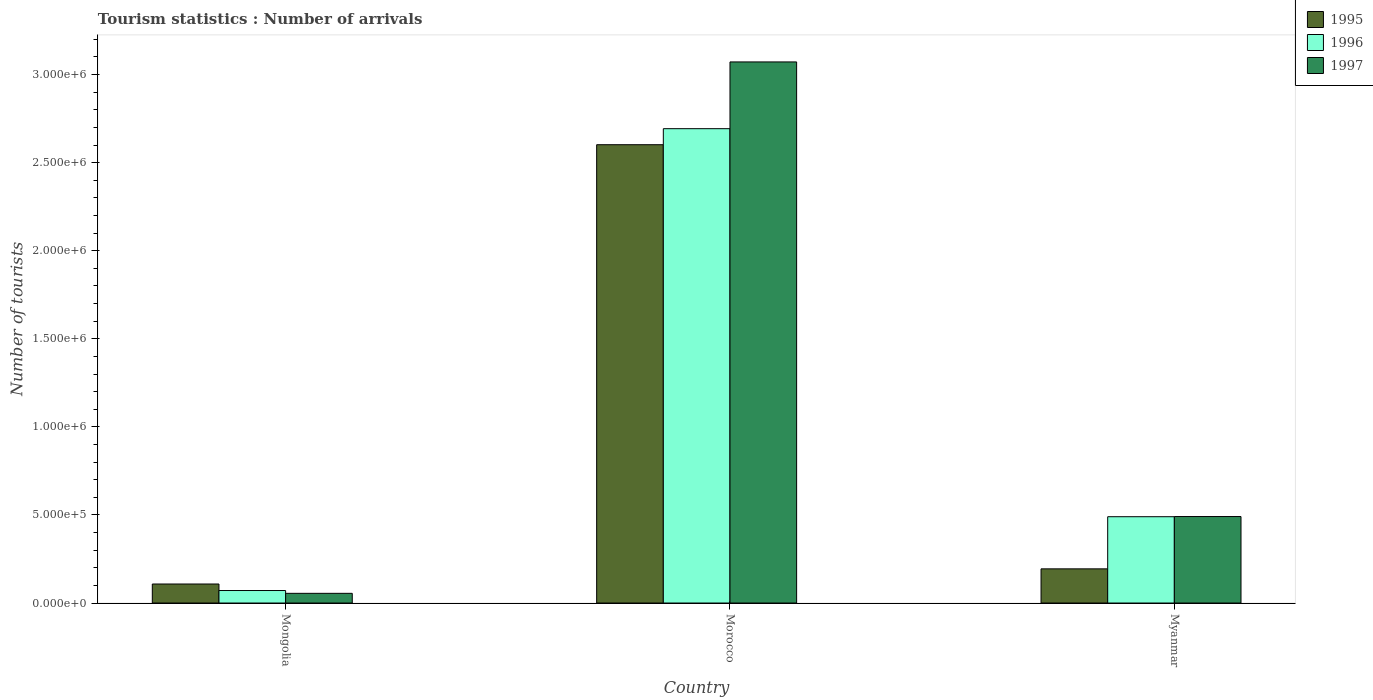How many different coloured bars are there?
Offer a terse response. 3. How many groups of bars are there?
Offer a terse response. 3. How many bars are there on the 2nd tick from the left?
Provide a short and direct response. 3. What is the label of the 2nd group of bars from the left?
Provide a succinct answer. Morocco. What is the number of tourist arrivals in 1995 in Myanmar?
Make the answer very short. 1.94e+05. Across all countries, what is the maximum number of tourist arrivals in 1997?
Ensure brevity in your answer.  3.07e+06. Across all countries, what is the minimum number of tourist arrivals in 1996?
Your response must be concise. 7.10e+04. In which country was the number of tourist arrivals in 1995 maximum?
Your answer should be very brief. Morocco. In which country was the number of tourist arrivals in 1996 minimum?
Give a very brief answer. Mongolia. What is the total number of tourist arrivals in 1996 in the graph?
Provide a succinct answer. 3.25e+06. What is the difference between the number of tourist arrivals in 1997 in Morocco and that in Myanmar?
Make the answer very short. 2.58e+06. What is the difference between the number of tourist arrivals in 1996 in Morocco and the number of tourist arrivals in 1997 in Myanmar?
Your response must be concise. 2.20e+06. What is the average number of tourist arrivals in 1996 per country?
Make the answer very short. 1.08e+06. What is the ratio of the number of tourist arrivals in 1997 in Morocco to that in Myanmar?
Ensure brevity in your answer.  6.26. Is the number of tourist arrivals in 1996 in Mongolia less than that in Morocco?
Offer a terse response. Yes. What is the difference between the highest and the second highest number of tourist arrivals in 1995?
Provide a short and direct response. 2.49e+06. What is the difference between the highest and the lowest number of tourist arrivals in 1997?
Keep it short and to the point. 3.02e+06. In how many countries, is the number of tourist arrivals in 1995 greater than the average number of tourist arrivals in 1995 taken over all countries?
Make the answer very short. 1. Is the sum of the number of tourist arrivals in 1996 in Mongolia and Myanmar greater than the maximum number of tourist arrivals in 1995 across all countries?
Give a very brief answer. No. What does the 1st bar from the left in Mongolia represents?
Your response must be concise. 1995. What does the 2nd bar from the right in Mongolia represents?
Your response must be concise. 1996. Are all the bars in the graph horizontal?
Keep it short and to the point. No. What is the difference between two consecutive major ticks on the Y-axis?
Provide a short and direct response. 5.00e+05. How many legend labels are there?
Offer a very short reply. 3. What is the title of the graph?
Provide a succinct answer. Tourism statistics : Number of arrivals. What is the label or title of the X-axis?
Offer a terse response. Country. What is the label or title of the Y-axis?
Your response must be concise. Number of tourists. What is the Number of tourists in 1995 in Mongolia?
Keep it short and to the point. 1.08e+05. What is the Number of tourists of 1996 in Mongolia?
Your answer should be very brief. 7.10e+04. What is the Number of tourists in 1997 in Mongolia?
Make the answer very short. 5.50e+04. What is the Number of tourists in 1995 in Morocco?
Offer a very short reply. 2.60e+06. What is the Number of tourists in 1996 in Morocco?
Keep it short and to the point. 2.69e+06. What is the Number of tourists in 1997 in Morocco?
Make the answer very short. 3.07e+06. What is the Number of tourists in 1995 in Myanmar?
Ensure brevity in your answer.  1.94e+05. What is the Number of tourists of 1996 in Myanmar?
Ensure brevity in your answer.  4.90e+05. What is the Number of tourists in 1997 in Myanmar?
Provide a succinct answer. 4.91e+05. Across all countries, what is the maximum Number of tourists in 1995?
Your answer should be very brief. 2.60e+06. Across all countries, what is the maximum Number of tourists of 1996?
Offer a very short reply. 2.69e+06. Across all countries, what is the maximum Number of tourists in 1997?
Your answer should be compact. 3.07e+06. Across all countries, what is the minimum Number of tourists of 1995?
Your answer should be very brief. 1.08e+05. Across all countries, what is the minimum Number of tourists in 1996?
Your response must be concise. 7.10e+04. Across all countries, what is the minimum Number of tourists of 1997?
Provide a short and direct response. 5.50e+04. What is the total Number of tourists of 1995 in the graph?
Your answer should be compact. 2.90e+06. What is the total Number of tourists of 1996 in the graph?
Keep it short and to the point. 3.25e+06. What is the total Number of tourists in 1997 in the graph?
Your response must be concise. 3.62e+06. What is the difference between the Number of tourists of 1995 in Mongolia and that in Morocco?
Ensure brevity in your answer.  -2.49e+06. What is the difference between the Number of tourists of 1996 in Mongolia and that in Morocco?
Offer a very short reply. -2.62e+06. What is the difference between the Number of tourists of 1997 in Mongolia and that in Morocco?
Offer a very short reply. -3.02e+06. What is the difference between the Number of tourists in 1995 in Mongolia and that in Myanmar?
Give a very brief answer. -8.60e+04. What is the difference between the Number of tourists of 1996 in Mongolia and that in Myanmar?
Give a very brief answer. -4.19e+05. What is the difference between the Number of tourists of 1997 in Mongolia and that in Myanmar?
Provide a short and direct response. -4.36e+05. What is the difference between the Number of tourists in 1995 in Morocco and that in Myanmar?
Ensure brevity in your answer.  2.41e+06. What is the difference between the Number of tourists in 1996 in Morocco and that in Myanmar?
Your answer should be very brief. 2.20e+06. What is the difference between the Number of tourists in 1997 in Morocco and that in Myanmar?
Give a very brief answer. 2.58e+06. What is the difference between the Number of tourists in 1995 in Mongolia and the Number of tourists in 1996 in Morocco?
Give a very brief answer. -2.58e+06. What is the difference between the Number of tourists in 1995 in Mongolia and the Number of tourists in 1997 in Morocco?
Give a very brief answer. -2.96e+06. What is the difference between the Number of tourists in 1996 in Mongolia and the Number of tourists in 1997 in Morocco?
Your answer should be very brief. -3.00e+06. What is the difference between the Number of tourists of 1995 in Mongolia and the Number of tourists of 1996 in Myanmar?
Your response must be concise. -3.82e+05. What is the difference between the Number of tourists in 1995 in Mongolia and the Number of tourists in 1997 in Myanmar?
Provide a succinct answer. -3.83e+05. What is the difference between the Number of tourists of 1996 in Mongolia and the Number of tourists of 1997 in Myanmar?
Make the answer very short. -4.20e+05. What is the difference between the Number of tourists in 1995 in Morocco and the Number of tourists in 1996 in Myanmar?
Keep it short and to the point. 2.11e+06. What is the difference between the Number of tourists in 1995 in Morocco and the Number of tourists in 1997 in Myanmar?
Provide a short and direct response. 2.11e+06. What is the difference between the Number of tourists of 1996 in Morocco and the Number of tourists of 1997 in Myanmar?
Provide a short and direct response. 2.20e+06. What is the average Number of tourists in 1995 per country?
Give a very brief answer. 9.68e+05. What is the average Number of tourists of 1996 per country?
Ensure brevity in your answer.  1.08e+06. What is the average Number of tourists of 1997 per country?
Make the answer very short. 1.21e+06. What is the difference between the Number of tourists in 1995 and Number of tourists in 1996 in Mongolia?
Keep it short and to the point. 3.70e+04. What is the difference between the Number of tourists of 1995 and Number of tourists of 1997 in Mongolia?
Provide a short and direct response. 5.30e+04. What is the difference between the Number of tourists of 1996 and Number of tourists of 1997 in Mongolia?
Keep it short and to the point. 1.60e+04. What is the difference between the Number of tourists in 1995 and Number of tourists in 1996 in Morocco?
Ensure brevity in your answer.  -9.10e+04. What is the difference between the Number of tourists of 1995 and Number of tourists of 1997 in Morocco?
Your answer should be very brief. -4.70e+05. What is the difference between the Number of tourists of 1996 and Number of tourists of 1997 in Morocco?
Keep it short and to the point. -3.79e+05. What is the difference between the Number of tourists in 1995 and Number of tourists in 1996 in Myanmar?
Your answer should be compact. -2.96e+05. What is the difference between the Number of tourists of 1995 and Number of tourists of 1997 in Myanmar?
Offer a very short reply. -2.97e+05. What is the difference between the Number of tourists in 1996 and Number of tourists in 1997 in Myanmar?
Give a very brief answer. -1000. What is the ratio of the Number of tourists of 1995 in Mongolia to that in Morocco?
Your answer should be compact. 0.04. What is the ratio of the Number of tourists in 1996 in Mongolia to that in Morocco?
Your answer should be very brief. 0.03. What is the ratio of the Number of tourists in 1997 in Mongolia to that in Morocco?
Provide a succinct answer. 0.02. What is the ratio of the Number of tourists in 1995 in Mongolia to that in Myanmar?
Your answer should be very brief. 0.56. What is the ratio of the Number of tourists of 1996 in Mongolia to that in Myanmar?
Provide a succinct answer. 0.14. What is the ratio of the Number of tourists of 1997 in Mongolia to that in Myanmar?
Your answer should be very brief. 0.11. What is the ratio of the Number of tourists of 1995 in Morocco to that in Myanmar?
Ensure brevity in your answer.  13.41. What is the ratio of the Number of tourists in 1996 in Morocco to that in Myanmar?
Give a very brief answer. 5.5. What is the ratio of the Number of tourists in 1997 in Morocco to that in Myanmar?
Provide a succinct answer. 6.26. What is the difference between the highest and the second highest Number of tourists of 1995?
Offer a terse response. 2.41e+06. What is the difference between the highest and the second highest Number of tourists in 1996?
Offer a terse response. 2.20e+06. What is the difference between the highest and the second highest Number of tourists of 1997?
Offer a very short reply. 2.58e+06. What is the difference between the highest and the lowest Number of tourists in 1995?
Provide a short and direct response. 2.49e+06. What is the difference between the highest and the lowest Number of tourists of 1996?
Your answer should be very brief. 2.62e+06. What is the difference between the highest and the lowest Number of tourists of 1997?
Ensure brevity in your answer.  3.02e+06. 